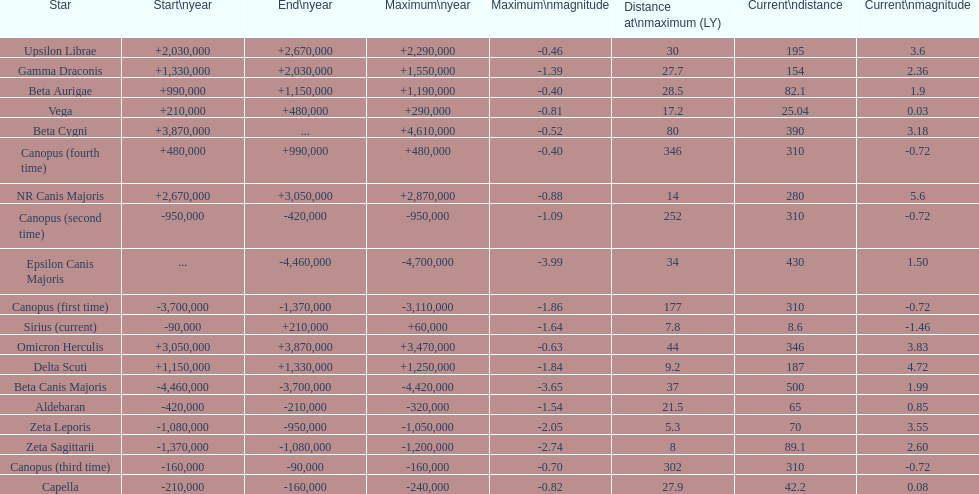Can you parse all the data within this table? {'header': ['Star', 'Start\\nyear', 'End\\nyear', 'Maximum\\nyear', 'Maximum\\nmagnitude', 'Distance at\\nmaximum (LY)', 'Current\\ndistance', 'Current\\nmagnitude'], 'rows': [['Upsilon Librae', '+2,030,000', '+2,670,000', '+2,290,000', '-0.46', '30', '195', '3.6'], ['Gamma Draconis', '+1,330,000', '+2,030,000', '+1,550,000', '-1.39', '27.7', '154', '2.36'], ['Beta Aurigae', '+990,000', '+1,150,000', '+1,190,000', '-0.40', '28.5', '82.1', '1.9'], ['Vega', '+210,000', '+480,000', '+290,000', '-0.81', '17.2', '25.04', '0.03'], ['Beta Cygni', '+3,870,000', '...', '+4,610,000', '-0.52', '80', '390', '3.18'], ['Canopus (fourth time)', '+480,000', '+990,000', '+480,000', '-0.40', '346', '310', '-0.72'], ['NR Canis Majoris', '+2,670,000', '+3,050,000', '+2,870,000', '-0.88', '14', '280', '5.6'], ['Canopus (second time)', '-950,000', '-420,000', '-950,000', '-1.09', '252', '310', '-0.72'], ['Epsilon Canis Majoris', '...', '-4,460,000', '-4,700,000', '-3.99', '34', '430', '1.50'], ['Canopus (first time)', '-3,700,000', '-1,370,000', '-3,110,000', '-1.86', '177', '310', '-0.72'], ['Sirius (current)', '-90,000', '+210,000', '+60,000', '-1.64', '7.8', '8.6', '-1.46'], ['Omicron Herculis', '+3,050,000', '+3,870,000', '+3,470,000', '-0.63', '44', '346', '3.83'], ['Delta Scuti', '+1,150,000', '+1,330,000', '+1,250,000', '-1.84', '9.2', '187', '4.72'], ['Beta Canis Majoris', '-4,460,000', '-3,700,000', '-4,420,000', '-3.65', '37', '500', '1.99'], ['Aldebaran', '-420,000', '-210,000', '-320,000', '-1.54', '21.5', '65', '0.85'], ['Zeta Leporis', '-1,080,000', '-950,000', '-1,050,000', '-2.05', '5.3', '70', '3.55'], ['Zeta Sagittarii', '-1,370,000', '-1,080,000', '-1,200,000', '-2.74', '8', '89.1', '2.60'], ['Canopus (third time)', '-160,000', '-90,000', '-160,000', '-0.70', '302', '310', '-0.72'], ['Capella', '-210,000', '-160,000', '-240,000', '-0.82', '27.9', '42.2', '0.08']]} How much farther (in ly) is epsilon canis majoris than zeta sagittarii? 26. 